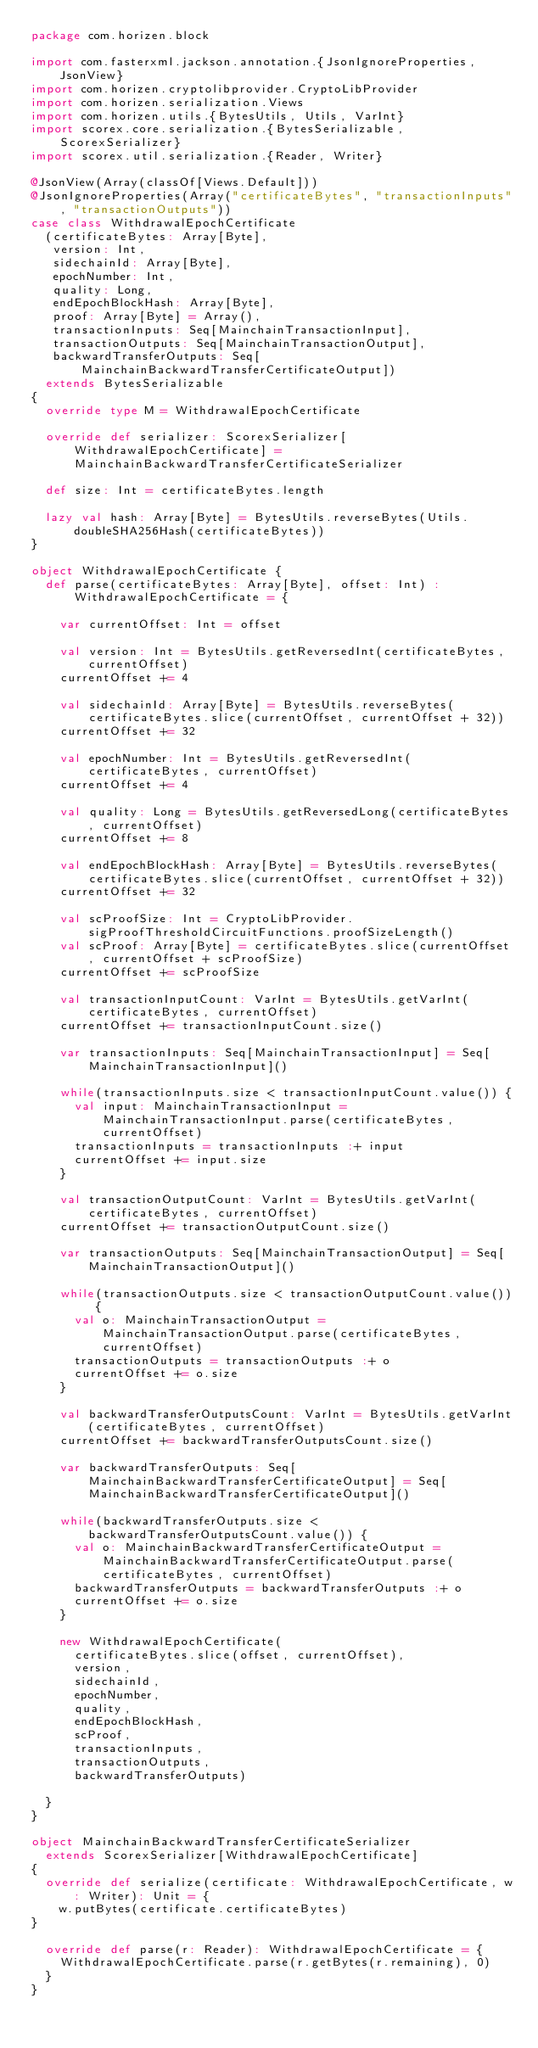<code> <loc_0><loc_0><loc_500><loc_500><_Scala_>package com.horizen.block

import com.fasterxml.jackson.annotation.{JsonIgnoreProperties, JsonView}
import com.horizen.cryptolibprovider.CryptoLibProvider
import com.horizen.serialization.Views
import com.horizen.utils.{BytesUtils, Utils, VarInt}
import scorex.core.serialization.{BytesSerializable, ScorexSerializer}
import scorex.util.serialization.{Reader, Writer}

@JsonView(Array(classOf[Views.Default]))
@JsonIgnoreProperties(Array("certificateBytes", "transactionInputs", "transactionOutputs"))
case class WithdrawalEpochCertificate
  (certificateBytes: Array[Byte],
   version: Int,
   sidechainId: Array[Byte],
   epochNumber: Int,
   quality: Long,
   endEpochBlockHash: Array[Byte],
   proof: Array[Byte] = Array(),
   transactionInputs: Seq[MainchainTransactionInput],
   transactionOutputs: Seq[MainchainTransactionOutput],
   backwardTransferOutputs: Seq[MainchainBackwardTransferCertificateOutput])
  extends BytesSerializable
{
  override type M = WithdrawalEpochCertificate

  override def serializer: ScorexSerializer[WithdrawalEpochCertificate] = MainchainBackwardTransferCertificateSerializer

  def size: Int = certificateBytes.length

  lazy val hash: Array[Byte] = BytesUtils.reverseBytes(Utils.doubleSHA256Hash(certificateBytes))
}

object WithdrawalEpochCertificate {
  def parse(certificateBytes: Array[Byte], offset: Int) : WithdrawalEpochCertificate = {

    var currentOffset: Int = offset

    val version: Int = BytesUtils.getReversedInt(certificateBytes, currentOffset)
    currentOffset += 4

    val sidechainId: Array[Byte] = BytesUtils.reverseBytes(certificateBytes.slice(currentOffset, currentOffset + 32))
    currentOffset += 32

    val epochNumber: Int = BytesUtils.getReversedInt(certificateBytes, currentOffset)
    currentOffset += 4

    val quality: Long = BytesUtils.getReversedLong(certificateBytes, currentOffset)
    currentOffset += 8

    val endEpochBlockHash: Array[Byte] = BytesUtils.reverseBytes(certificateBytes.slice(currentOffset, currentOffset + 32))
    currentOffset += 32

    val scProofSize: Int = CryptoLibProvider.sigProofThresholdCircuitFunctions.proofSizeLength()
    val scProof: Array[Byte] = certificateBytes.slice(currentOffset, currentOffset + scProofSize)
    currentOffset += scProofSize

    val transactionInputCount: VarInt = BytesUtils.getVarInt(certificateBytes, currentOffset)
    currentOffset += transactionInputCount.size()

    var transactionInputs: Seq[MainchainTransactionInput] = Seq[MainchainTransactionInput]()

    while(transactionInputs.size < transactionInputCount.value()) {
      val input: MainchainTransactionInput = MainchainTransactionInput.parse(certificateBytes, currentOffset)
      transactionInputs = transactionInputs :+ input
      currentOffset += input.size
    }

    val transactionOutputCount: VarInt = BytesUtils.getVarInt(certificateBytes, currentOffset)
    currentOffset += transactionOutputCount.size()

    var transactionOutputs: Seq[MainchainTransactionOutput] = Seq[MainchainTransactionOutput]()

    while(transactionOutputs.size < transactionOutputCount.value()) {
      val o: MainchainTransactionOutput = MainchainTransactionOutput.parse(certificateBytes, currentOffset)
      transactionOutputs = transactionOutputs :+ o
      currentOffset += o.size
    }

    val backwardTransferOutputsCount: VarInt = BytesUtils.getVarInt(certificateBytes, currentOffset)
    currentOffset += backwardTransferOutputsCount.size()

    var backwardTransferOutputs: Seq[MainchainBackwardTransferCertificateOutput] = Seq[MainchainBackwardTransferCertificateOutput]()

    while(backwardTransferOutputs.size < backwardTransferOutputsCount.value()) {
      val o: MainchainBackwardTransferCertificateOutput = MainchainBackwardTransferCertificateOutput.parse(certificateBytes, currentOffset)
      backwardTransferOutputs = backwardTransferOutputs :+ o
      currentOffset += o.size
    }

    new WithdrawalEpochCertificate(
      certificateBytes.slice(offset, currentOffset),
      version,
      sidechainId,
      epochNumber,
      quality,
      endEpochBlockHash,
      scProof,
      transactionInputs,
      transactionOutputs,
      backwardTransferOutputs)

  }
}

object MainchainBackwardTransferCertificateSerializer
  extends ScorexSerializer[WithdrawalEpochCertificate]
{
  override def serialize(certificate: WithdrawalEpochCertificate, w: Writer): Unit = {
    w.putBytes(certificate.certificateBytes)
}

  override def parse(r: Reader): WithdrawalEpochCertificate = {
    WithdrawalEpochCertificate.parse(r.getBytes(r.remaining), 0)
  }
}
</code> 